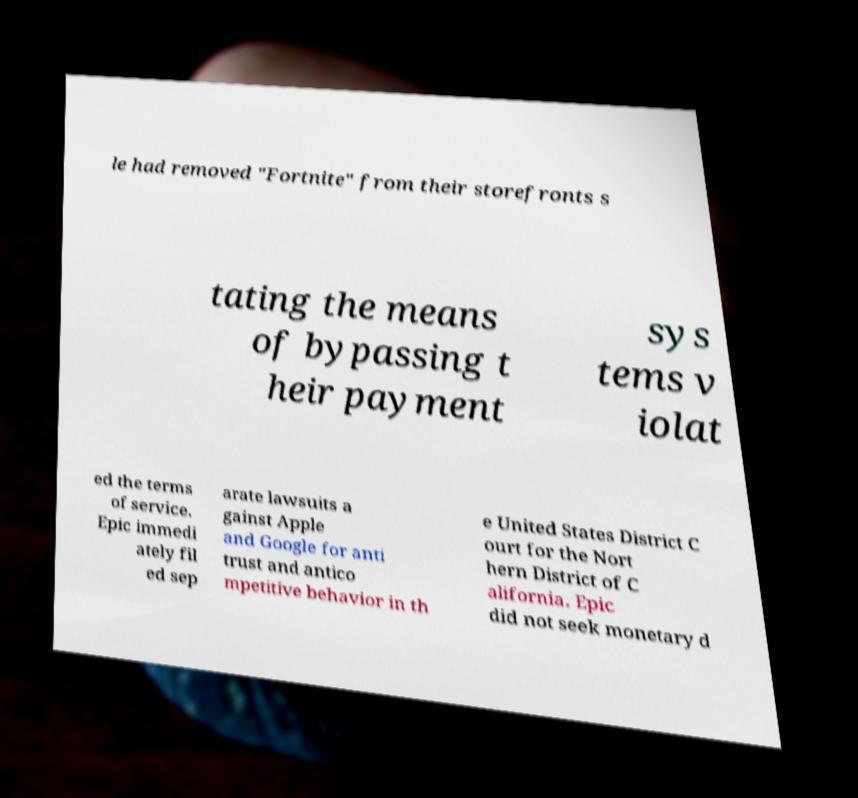Please identify and transcribe the text found in this image. le had removed "Fortnite" from their storefronts s tating the means of bypassing t heir payment sys tems v iolat ed the terms of service. Epic immedi ately fil ed sep arate lawsuits a gainst Apple and Google for anti trust and antico mpetitive behavior in th e United States District C ourt for the Nort hern District of C alifornia. Epic did not seek monetary d 